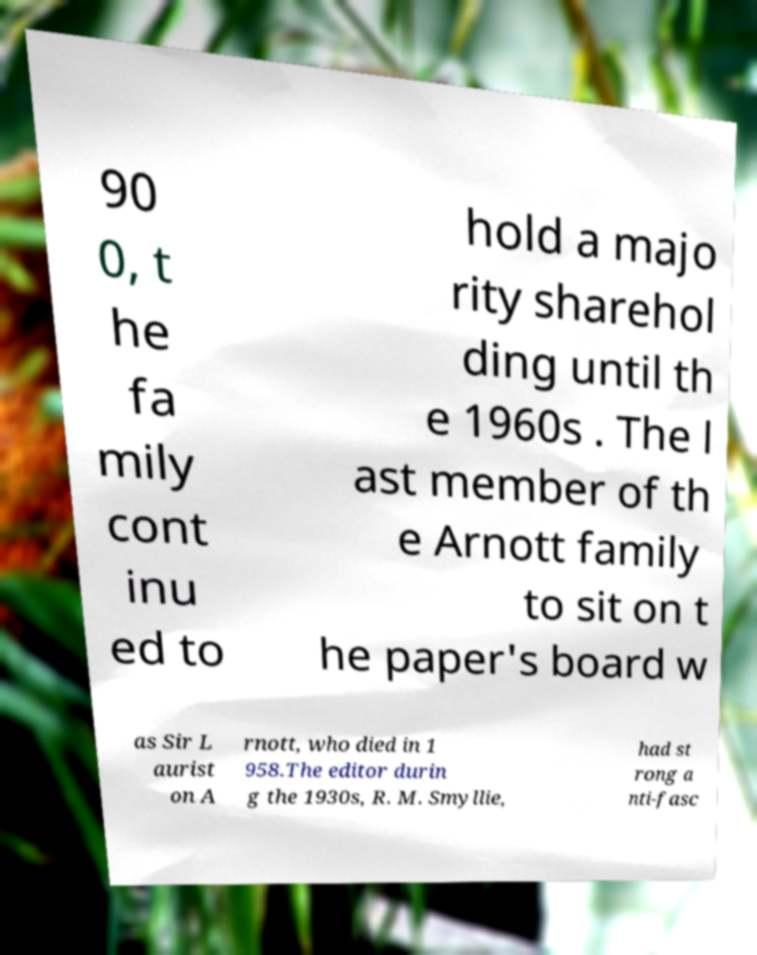Could you assist in decoding the text presented in this image and type it out clearly? 90 0, t he fa mily cont inu ed to hold a majo rity sharehol ding until th e 1960s . The l ast member of th e Arnott family to sit on t he paper's board w as Sir L aurist on A rnott, who died in 1 958.The editor durin g the 1930s, R. M. Smyllie, had st rong a nti-fasc 